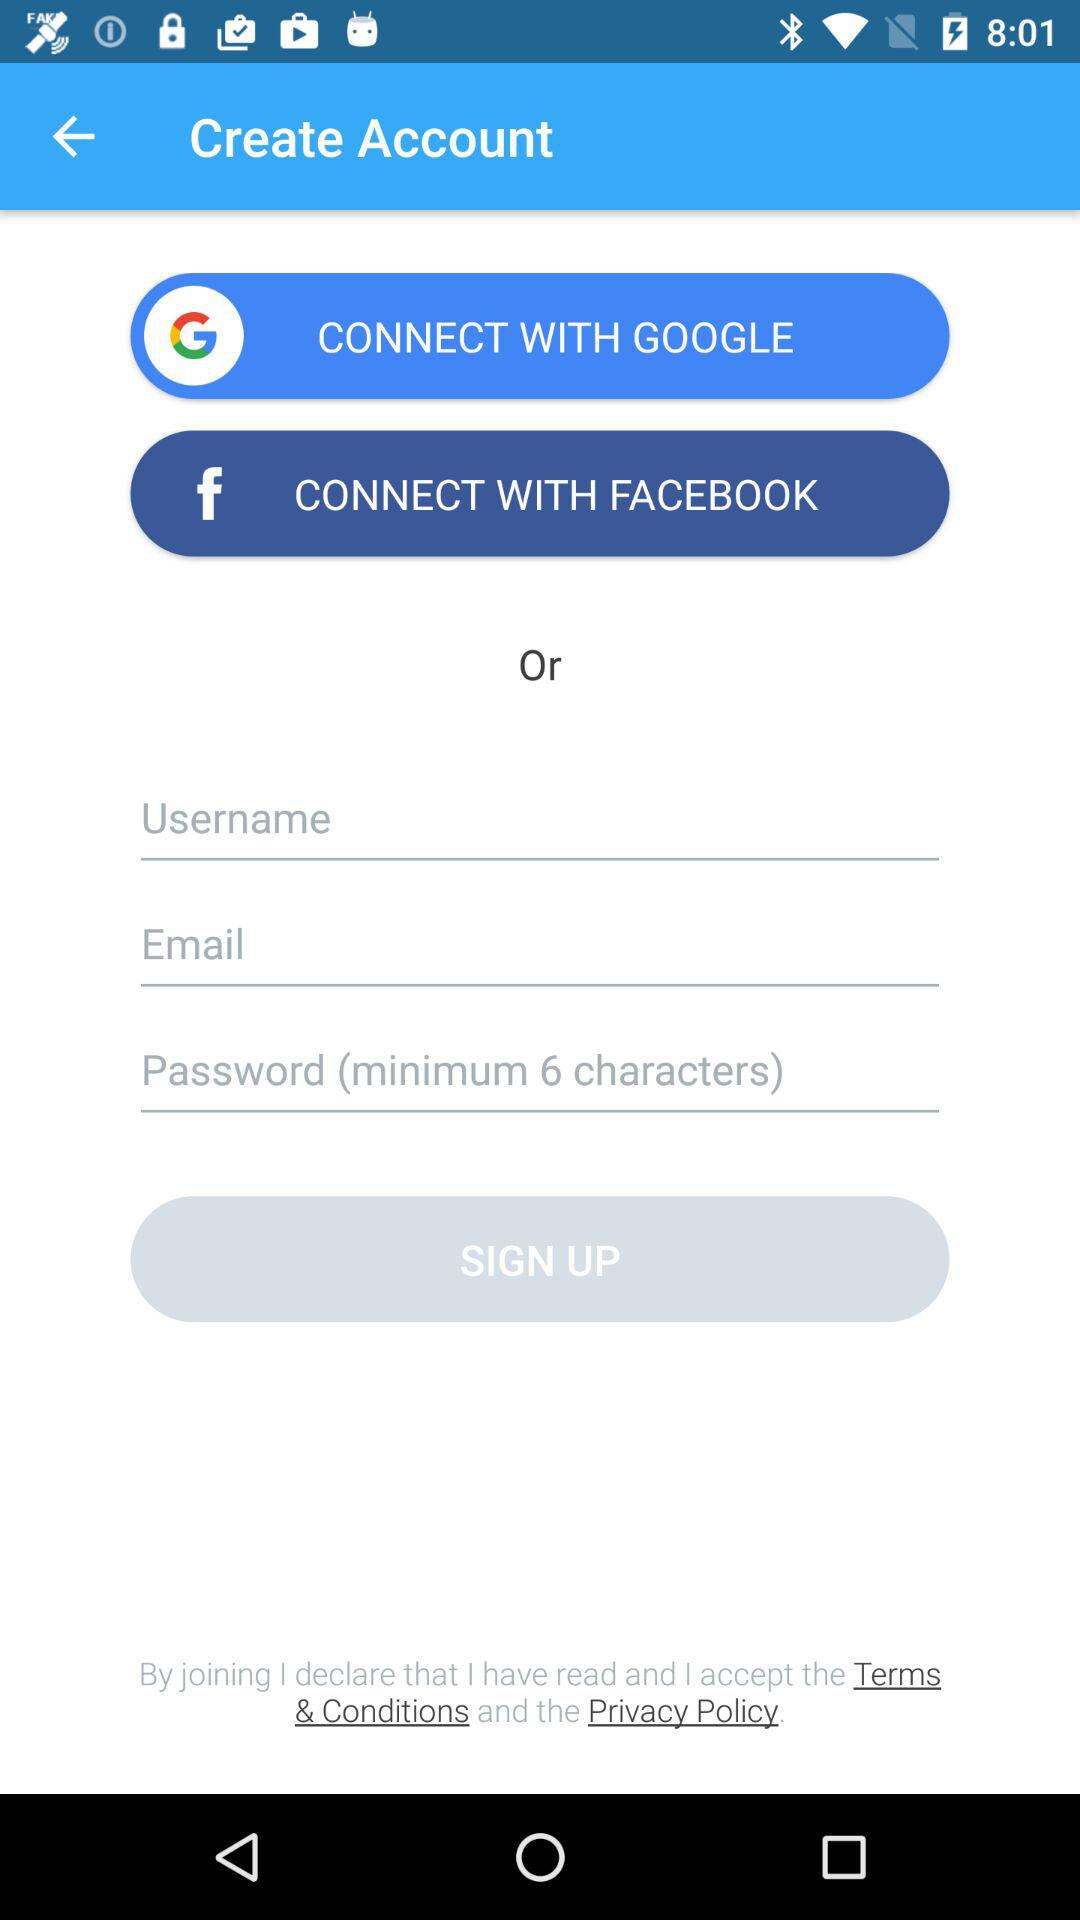What options are available to sign up? The available options are "GOOGLE", "FACEBOOK" and "Email". 